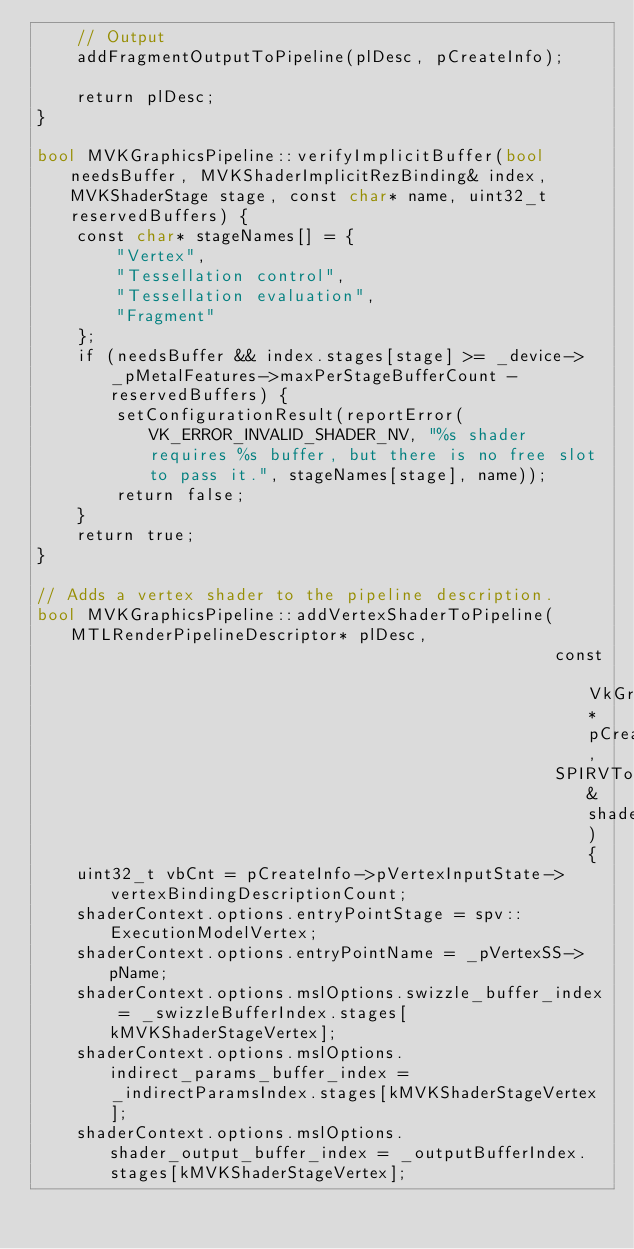Convert code to text. <code><loc_0><loc_0><loc_500><loc_500><_ObjectiveC_>	// Output
	addFragmentOutputToPipeline(plDesc, pCreateInfo);

	return plDesc;
}

bool MVKGraphicsPipeline::verifyImplicitBuffer(bool needsBuffer, MVKShaderImplicitRezBinding& index, MVKShaderStage stage, const char* name, uint32_t reservedBuffers) {
	const char* stageNames[] = {
		"Vertex",
		"Tessellation control",
		"Tessellation evaluation",
		"Fragment"
	};
	if (needsBuffer && index.stages[stage] >= _device->_pMetalFeatures->maxPerStageBufferCount - reservedBuffers) {
		setConfigurationResult(reportError(VK_ERROR_INVALID_SHADER_NV, "%s shader requires %s buffer, but there is no free slot to pass it.", stageNames[stage], name));
		return false;
	}
	return true;
}

// Adds a vertex shader to the pipeline description.
bool MVKGraphicsPipeline::addVertexShaderToPipeline(MTLRenderPipelineDescriptor* plDesc,
													const VkGraphicsPipelineCreateInfo* pCreateInfo,
													SPIRVToMSLConversionConfiguration& shaderContext) {
	uint32_t vbCnt = pCreateInfo->pVertexInputState->vertexBindingDescriptionCount;
	shaderContext.options.entryPointStage = spv::ExecutionModelVertex;
	shaderContext.options.entryPointName = _pVertexSS->pName;
	shaderContext.options.mslOptions.swizzle_buffer_index = _swizzleBufferIndex.stages[kMVKShaderStageVertex];
	shaderContext.options.mslOptions.indirect_params_buffer_index = _indirectParamsIndex.stages[kMVKShaderStageVertex];
	shaderContext.options.mslOptions.shader_output_buffer_index = _outputBufferIndex.stages[kMVKShaderStageVertex];</code> 